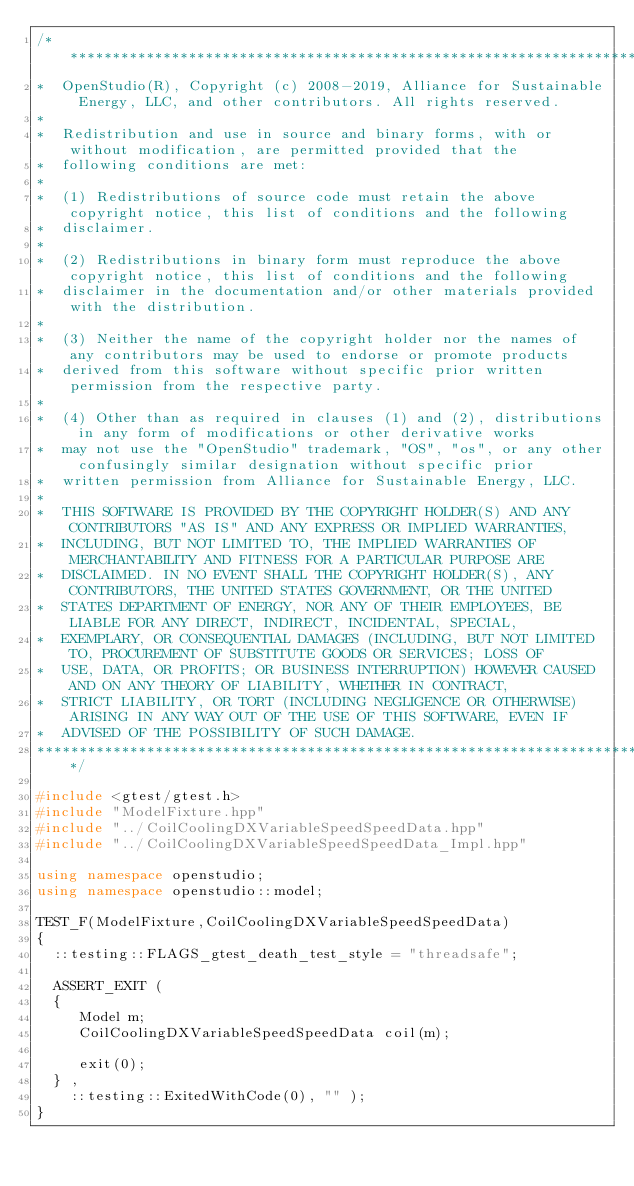<code> <loc_0><loc_0><loc_500><loc_500><_C++_>/***********************************************************************************************************************
*  OpenStudio(R), Copyright (c) 2008-2019, Alliance for Sustainable Energy, LLC, and other contributors. All rights reserved.
*
*  Redistribution and use in source and binary forms, with or without modification, are permitted provided that the
*  following conditions are met:
*
*  (1) Redistributions of source code must retain the above copyright notice, this list of conditions and the following
*  disclaimer.
*
*  (2) Redistributions in binary form must reproduce the above copyright notice, this list of conditions and the following
*  disclaimer in the documentation and/or other materials provided with the distribution.
*
*  (3) Neither the name of the copyright holder nor the names of any contributors may be used to endorse or promote products
*  derived from this software without specific prior written permission from the respective party.
*
*  (4) Other than as required in clauses (1) and (2), distributions in any form of modifications or other derivative works
*  may not use the "OpenStudio" trademark, "OS", "os", or any other confusingly similar designation without specific prior
*  written permission from Alliance for Sustainable Energy, LLC.
*
*  THIS SOFTWARE IS PROVIDED BY THE COPYRIGHT HOLDER(S) AND ANY CONTRIBUTORS "AS IS" AND ANY EXPRESS OR IMPLIED WARRANTIES,
*  INCLUDING, BUT NOT LIMITED TO, THE IMPLIED WARRANTIES OF MERCHANTABILITY AND FITNESS FOR A PARTICULAR PURPOSE ARE
*  DISCLAIMED. IN NO EVENT SHALL THE COPYRIGHT HOLDER(S), ANY CONTRIBUTORS, THE UNITED STATES GOVERNMENT, OR THE UNITED
*  STATES DEPARTMENT OF ENERGY, NOR ANY OF THEIR EMPLOYEES, BE LIABLE FOR ANY DIRECT, INDIRECT, INCIDENTAL, SPECIAL,
*  EXEMPLARY, OR CONSEQUENTIAL DAMAGES (INCLUDING, BUT NOT LIMITED TO, PROCUREMENT OF SUBSTITUTE GOODS OR SERVICES; LOSS OF
*  USE, DATA, OR PROFITS; OR BUSINESS INTERRUPTION) HOWEVER CAUSED AND ON ANY THEORY OF LIABILITY, WHETHER IN CONTRACT,
*  STRICT LIABILITY, OR TORT (INCLUDING NEGLIGENCE OR OTHERWISE) ARISING IN ANY WAY OUT OF THE USE OF THIS SOFTWARE, EVEN IF
*  ADVISED OF THE POSSIBILITY OF SUCH DAMAGE.
***********************************************************************************************************************/

#include <gtest/gtest.h>
#include "ModelFixture.hpp"
#include "../CoilCoolingDXVariableSpeedSpeedData.hpp"
#include "../CoilCoolingDXVariableSpeedSpeedData_Impl.hpp"

using namespace openstudio;
using namespace openstudio::model;

TEST_F(ModelFixture,CoilCoolingDXVariableSpeedSpeedData)
{
  ::testing::FLAGS_gtest_death_test_style = "threadsafe";

  ASSERT_EXIT (
  {
     Model m;
     CoilCoolingDXVariableSpeedSpeedData coil(m);

     exit(0);
  } ,
    ::testing::ExitedWithCode(0), "" );
}
</code> 